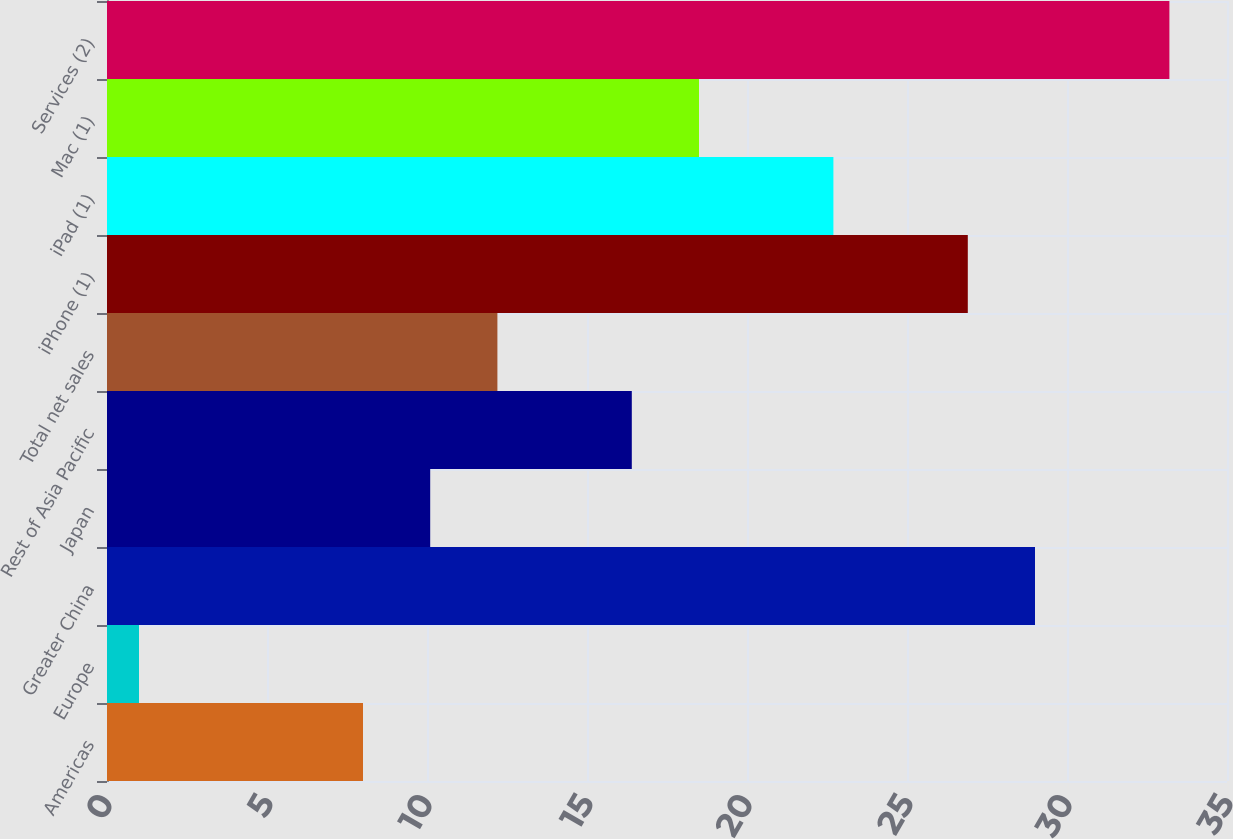Convert chart to OTSL. <chart><loc_0><loc_0><loc_500><loc_500><bar_chart><fcel>Americas<fcel>Europe<fcel>Greater China<fcel>Japan<fcel>Rest of Asia Pacific<fcel>Total net sales<fcel>iPhone (1)<fcel>iPad (1)<fcel>Mac (1)<fcel>Services (2)<nl><fcel>8<fcel>1<fcel>29<fcel>10.1<fcel>16.4<fcel>12.2<fcel>26.9<fcel>22.7<fcel>18.5<fcel>33.2<nl></chart> 